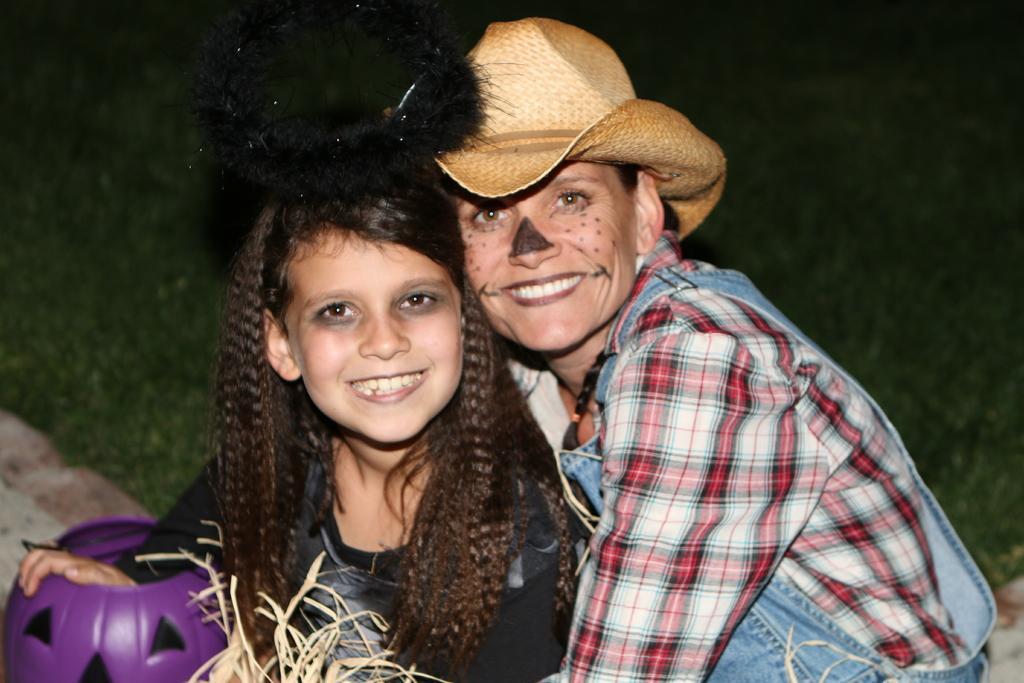Can you describe this image briefly? In this image I can see two people with different color dresses. I can see one person with the hat. I can see the purple color object in-front of these people. In the background I can see the grass. 